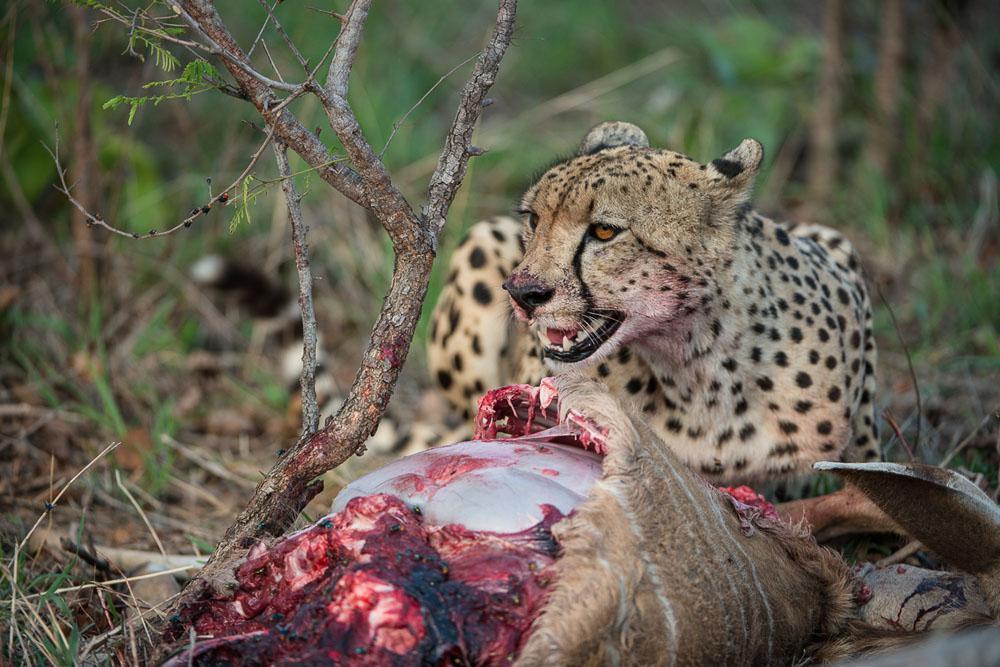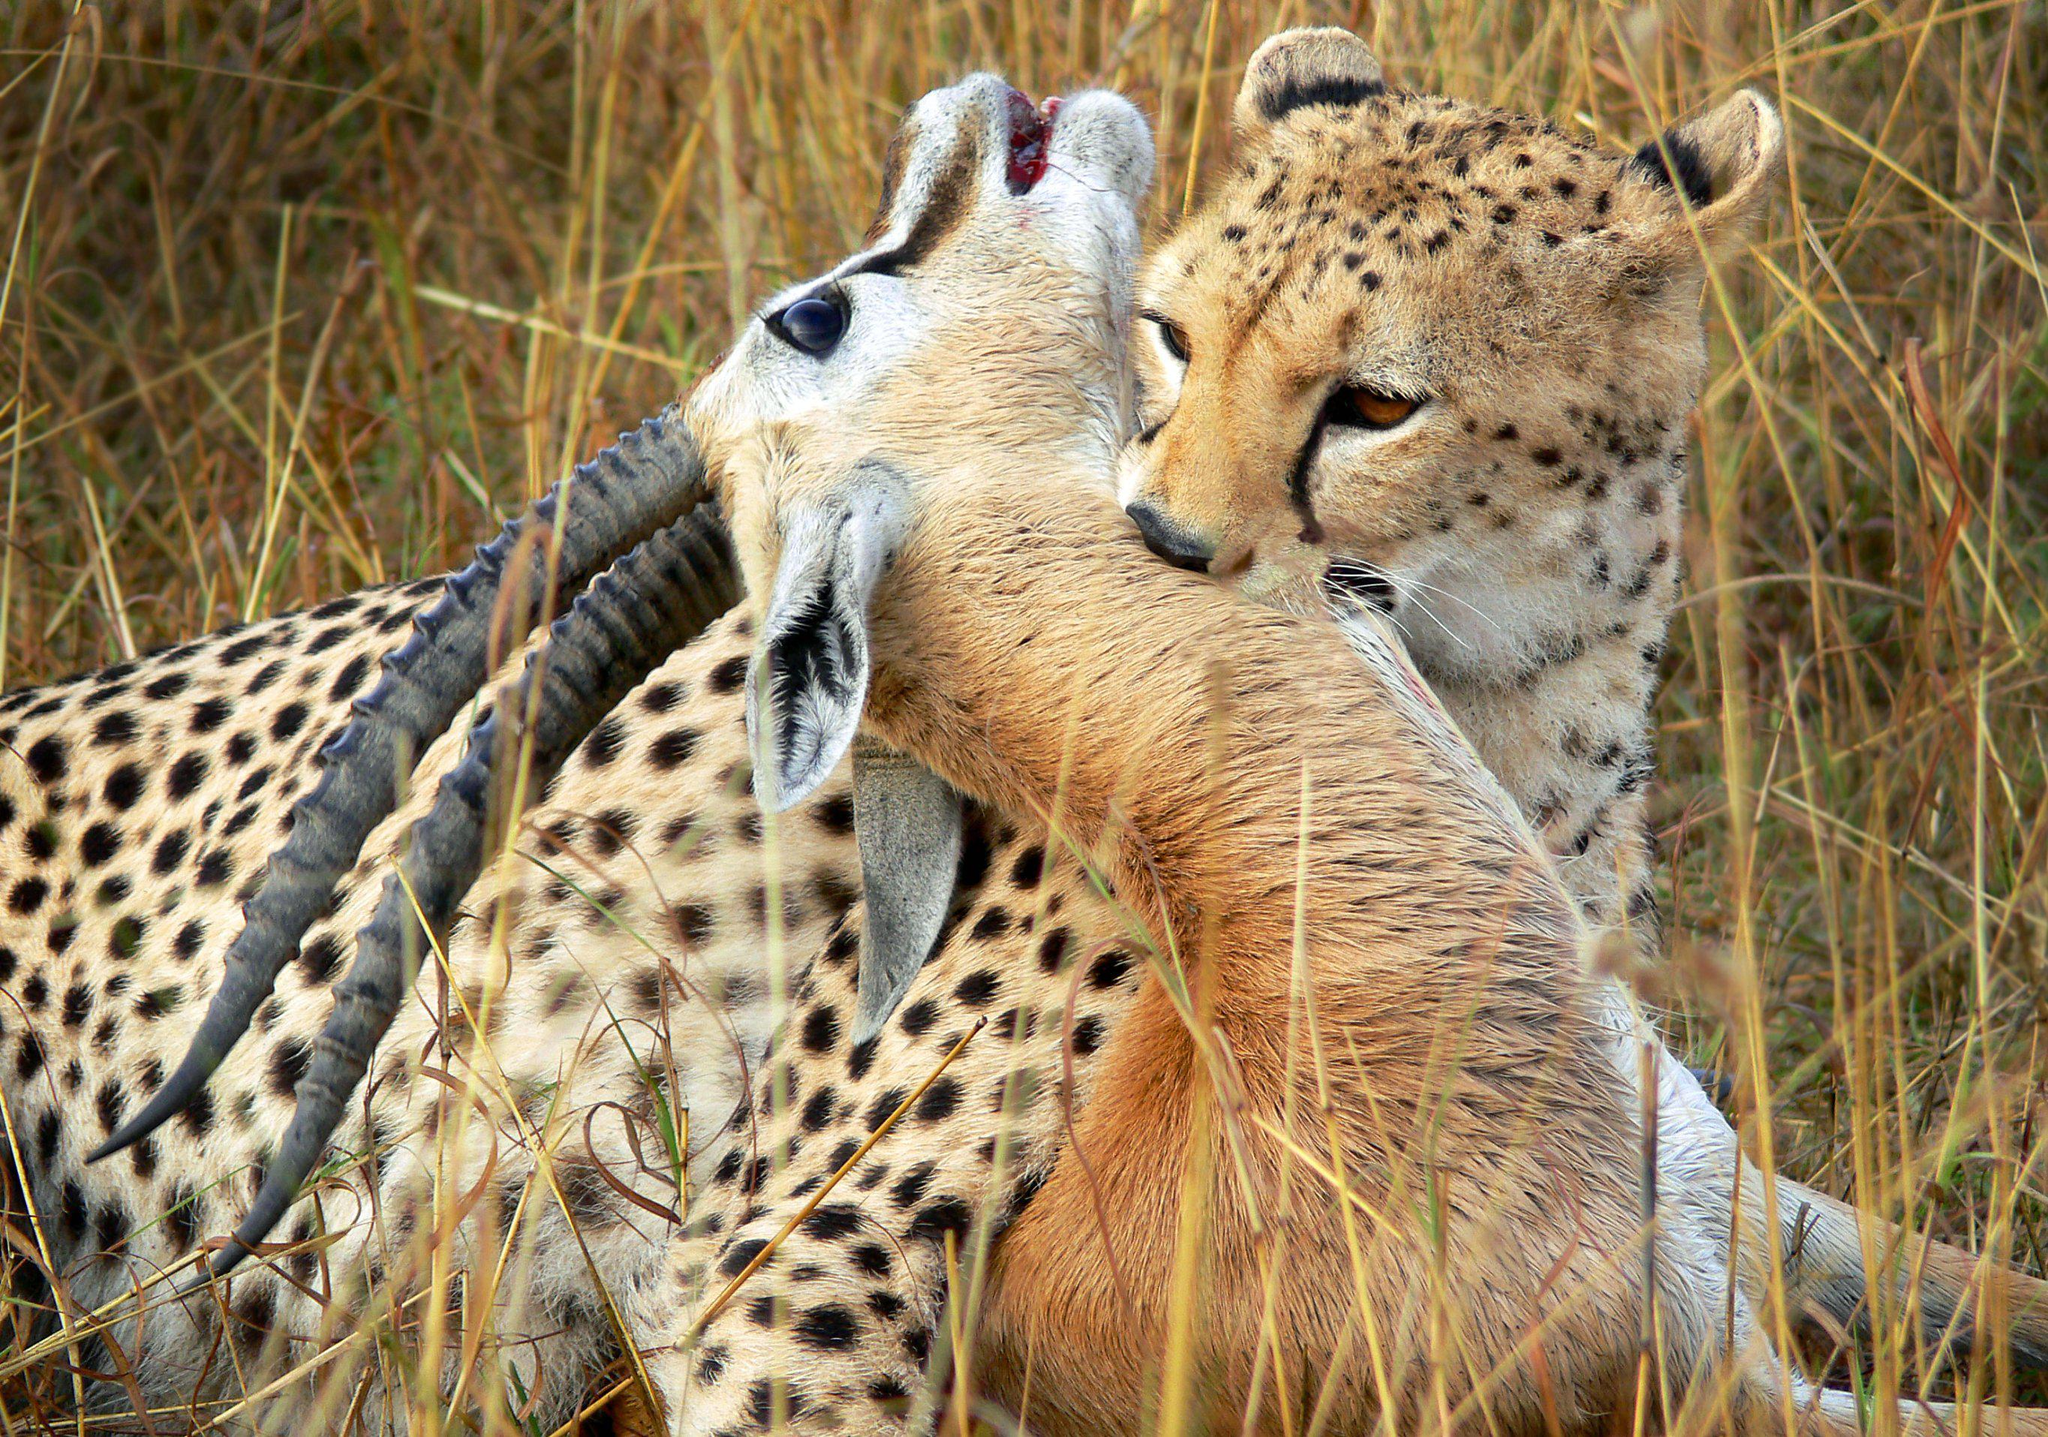The first image is the image on the left, the second image is the image on the right. Given the left and right images, does the statement "At least one cheetah is laying on a mound." hold true? Answer yes or no. No. The first image is the image on the left, the second image is the image on the right. Examine the images to the left and right. Is the description "There is at least one cheetah atop a grassy mound" accurate? Answer yes or no. No. 